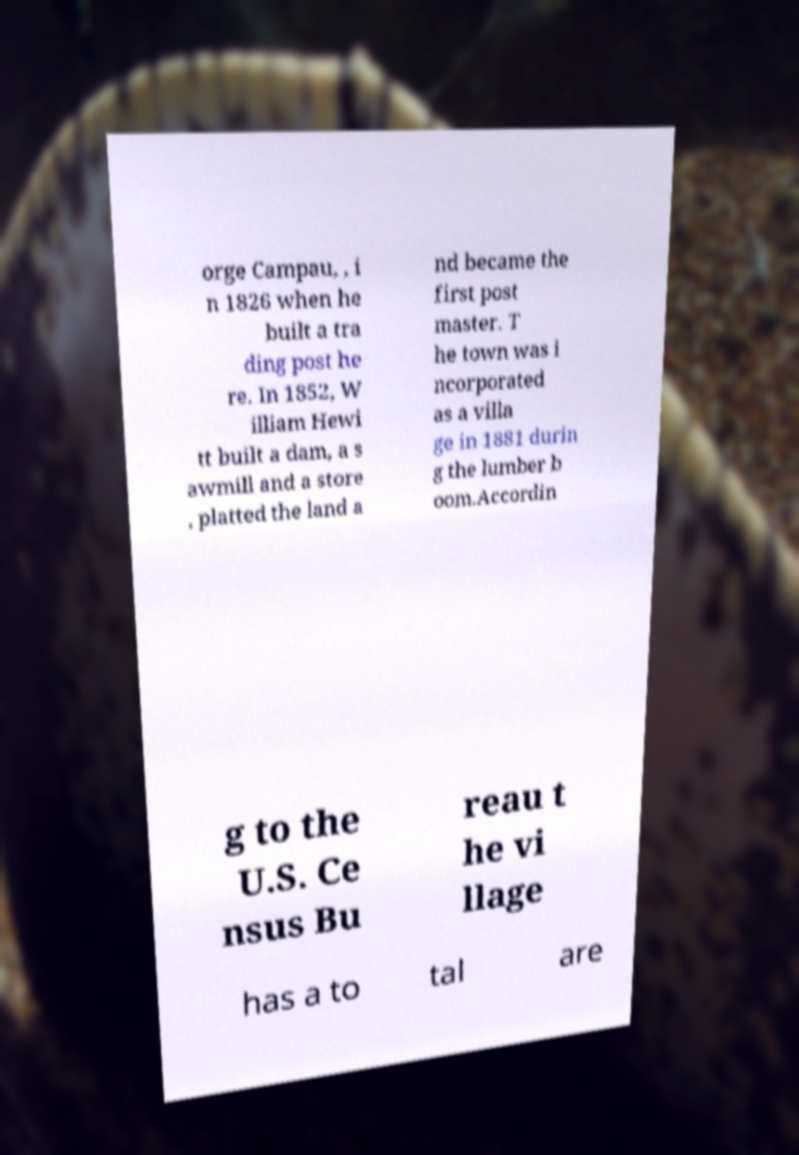I need the written content from this picture converted into text. Can you do that? orge Campau, , i n 1826 when he built a tra ding post he re. In 1852, W illiam Hewi tt built a dam, a s awmill and a store , platted the land a nd became the first post master. T he town was i ncorporated as a villa ge in 1881 durin g the lumber b oom.Accordin g to the U.S. Ce nsus Bu reau t he vi llage has a to tal are 